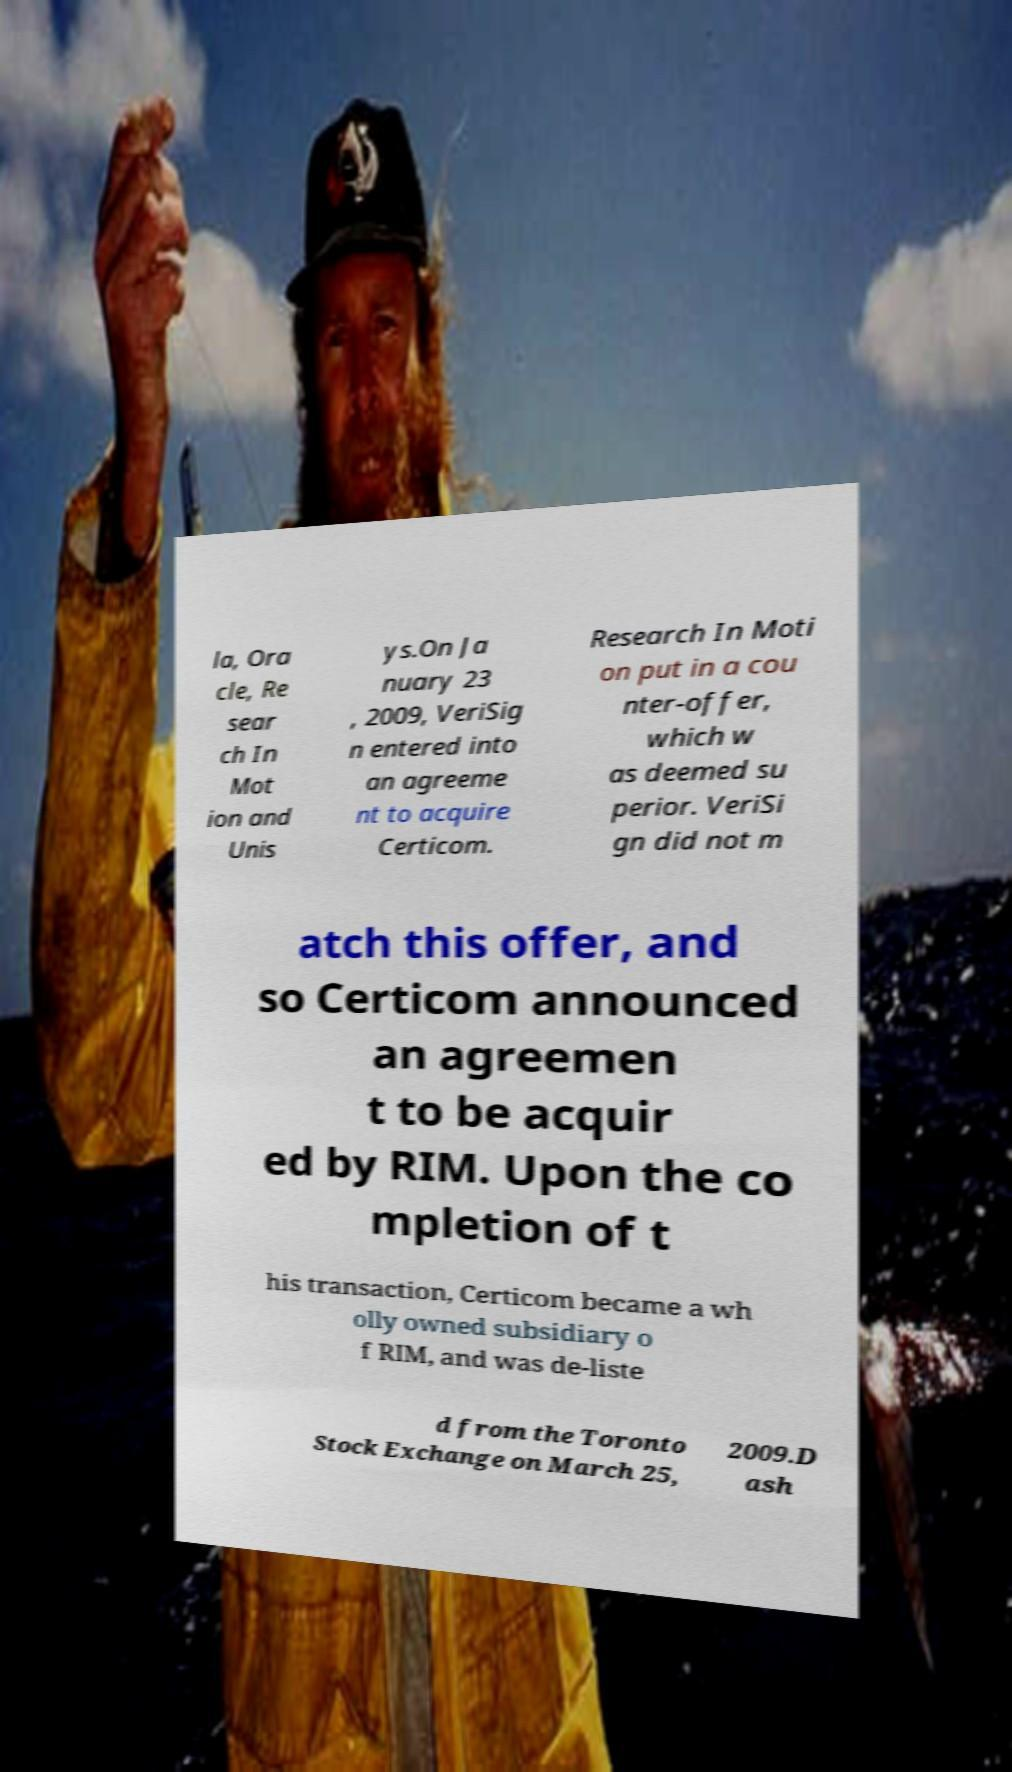Please identify and transcribe the text found in this image. la, Ora cle, Re sear ch In Mot ion and Unis ys.On Ja nuary 23 , 2009, VeriSig n entered into an agreeme nt to acquire Certicom. Research In Moti on put in a cou nter-offer, which w as deemed su perior. VeriSi gn did not m atch this offer, and so Certicom announced an agreemen t to be acquir ed by RIM. Upon the co mpletion of t his transaction, Certicom became a wh olly owned subsidiary o f RIM, and was de-liste d from the Toronto Stock Exchange on March 25, 2009.D ash 